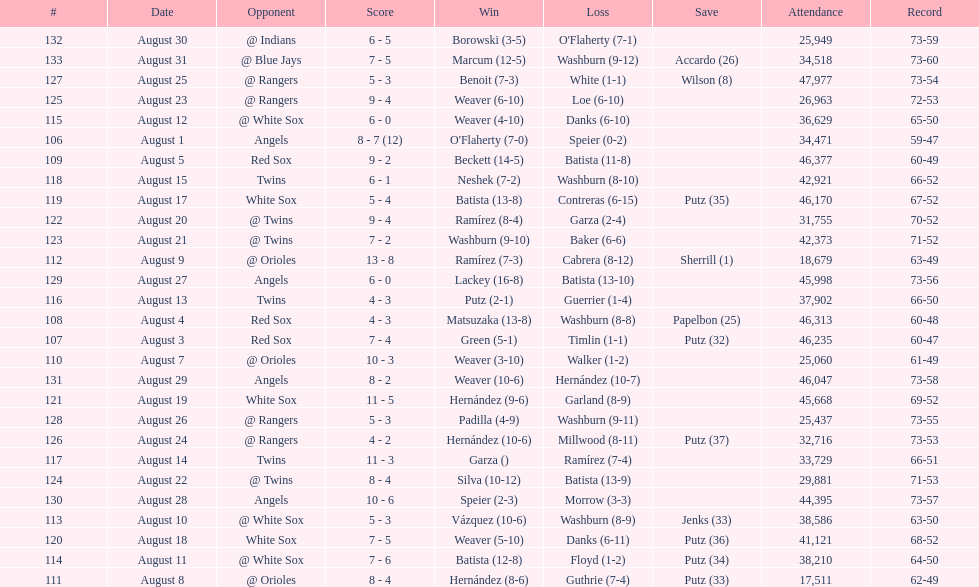Number of wins during stretch 5. 